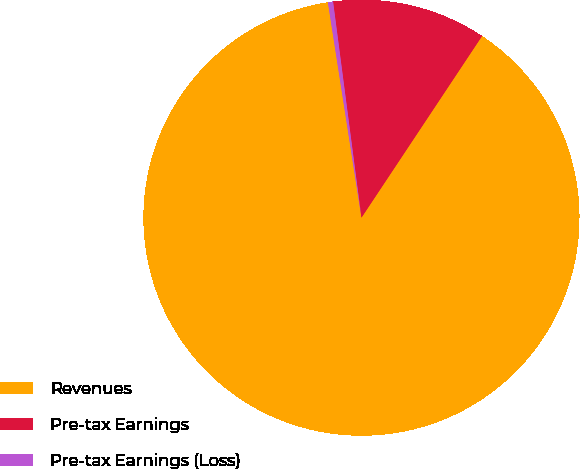<chart> <loc_0><loc_0><loc_500><loc_500><pie_chart><fcel>Revenues<fcel>Pre-tax Earnings<fcel>Pre-tax Earnings (Loss)<nl><fcel>88.22%<fcel>11.41%<fcel>0.38%<nl></chart> 